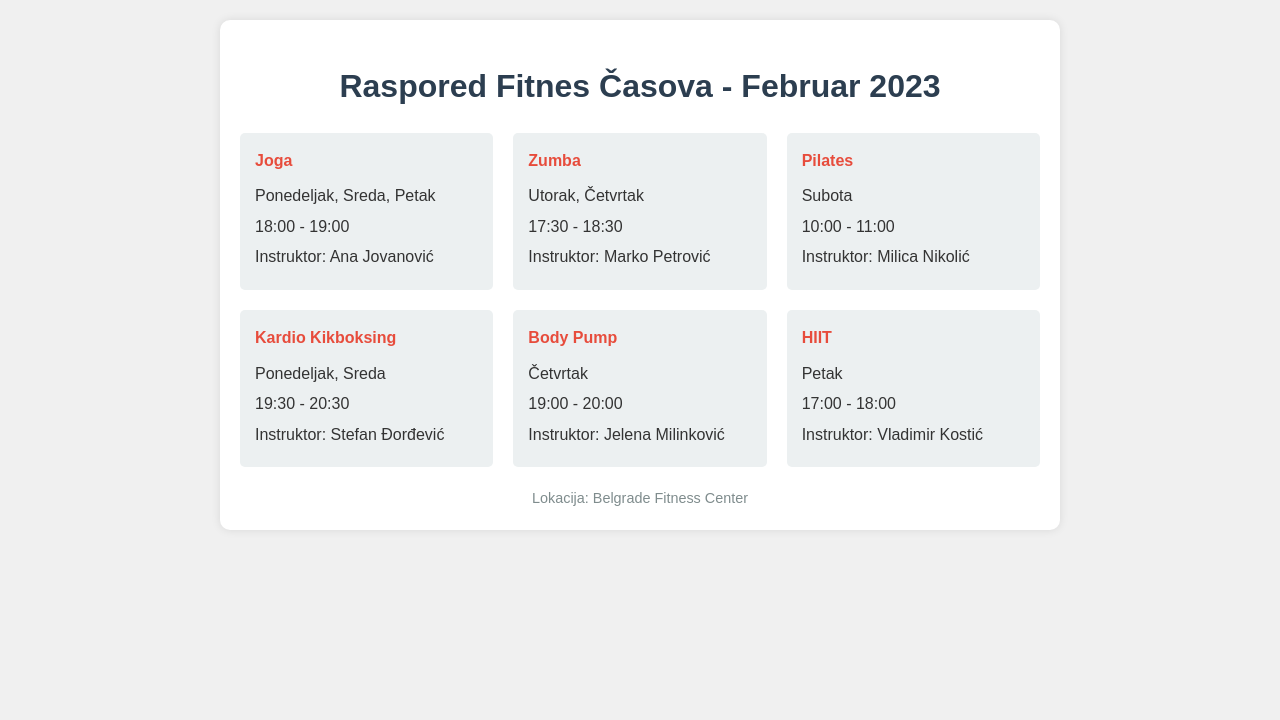What days does the Yoga class take place? The Yoga class is scheduled for Monday, Wednesday, and Friday as per the document.
Answer: Ponedeljak, Sreda, Petak Who is the instructor for Zumba? The Zumba instructor is listed as Marko Petrović in the document.
Answer: Marko Petrović What time does the Pilates class start? The Pilates class starts at 10:00 according to the schedule provided.
Answer: 10:00 On which day is the Body Pump class held? The document states that Body Pump is held on Thursday.
Answer: Četvrtak How many classes are there in total? There are a total of six fitness classes listed in the document.
Answer: 6 What is the duration of the HIIT class? The HIIT class is scheduled for one hour from 17:00 to 18:00 in the document.
Answer: 1 hour Which class is held at 19:30? The Kardio Kikboksing class is scheduled at 19:30 as mentioned in the document.
Answer: Kardio Kikboksing Where is the fitness center located? The document specifies that the location is the Belgrade Fitness Center.
Answer: Belgrade Fitness Center In which week day is the HIIT class scheduled? The HIIT class is scheduled on Fridays as noted in the document.
Answer: Petak 